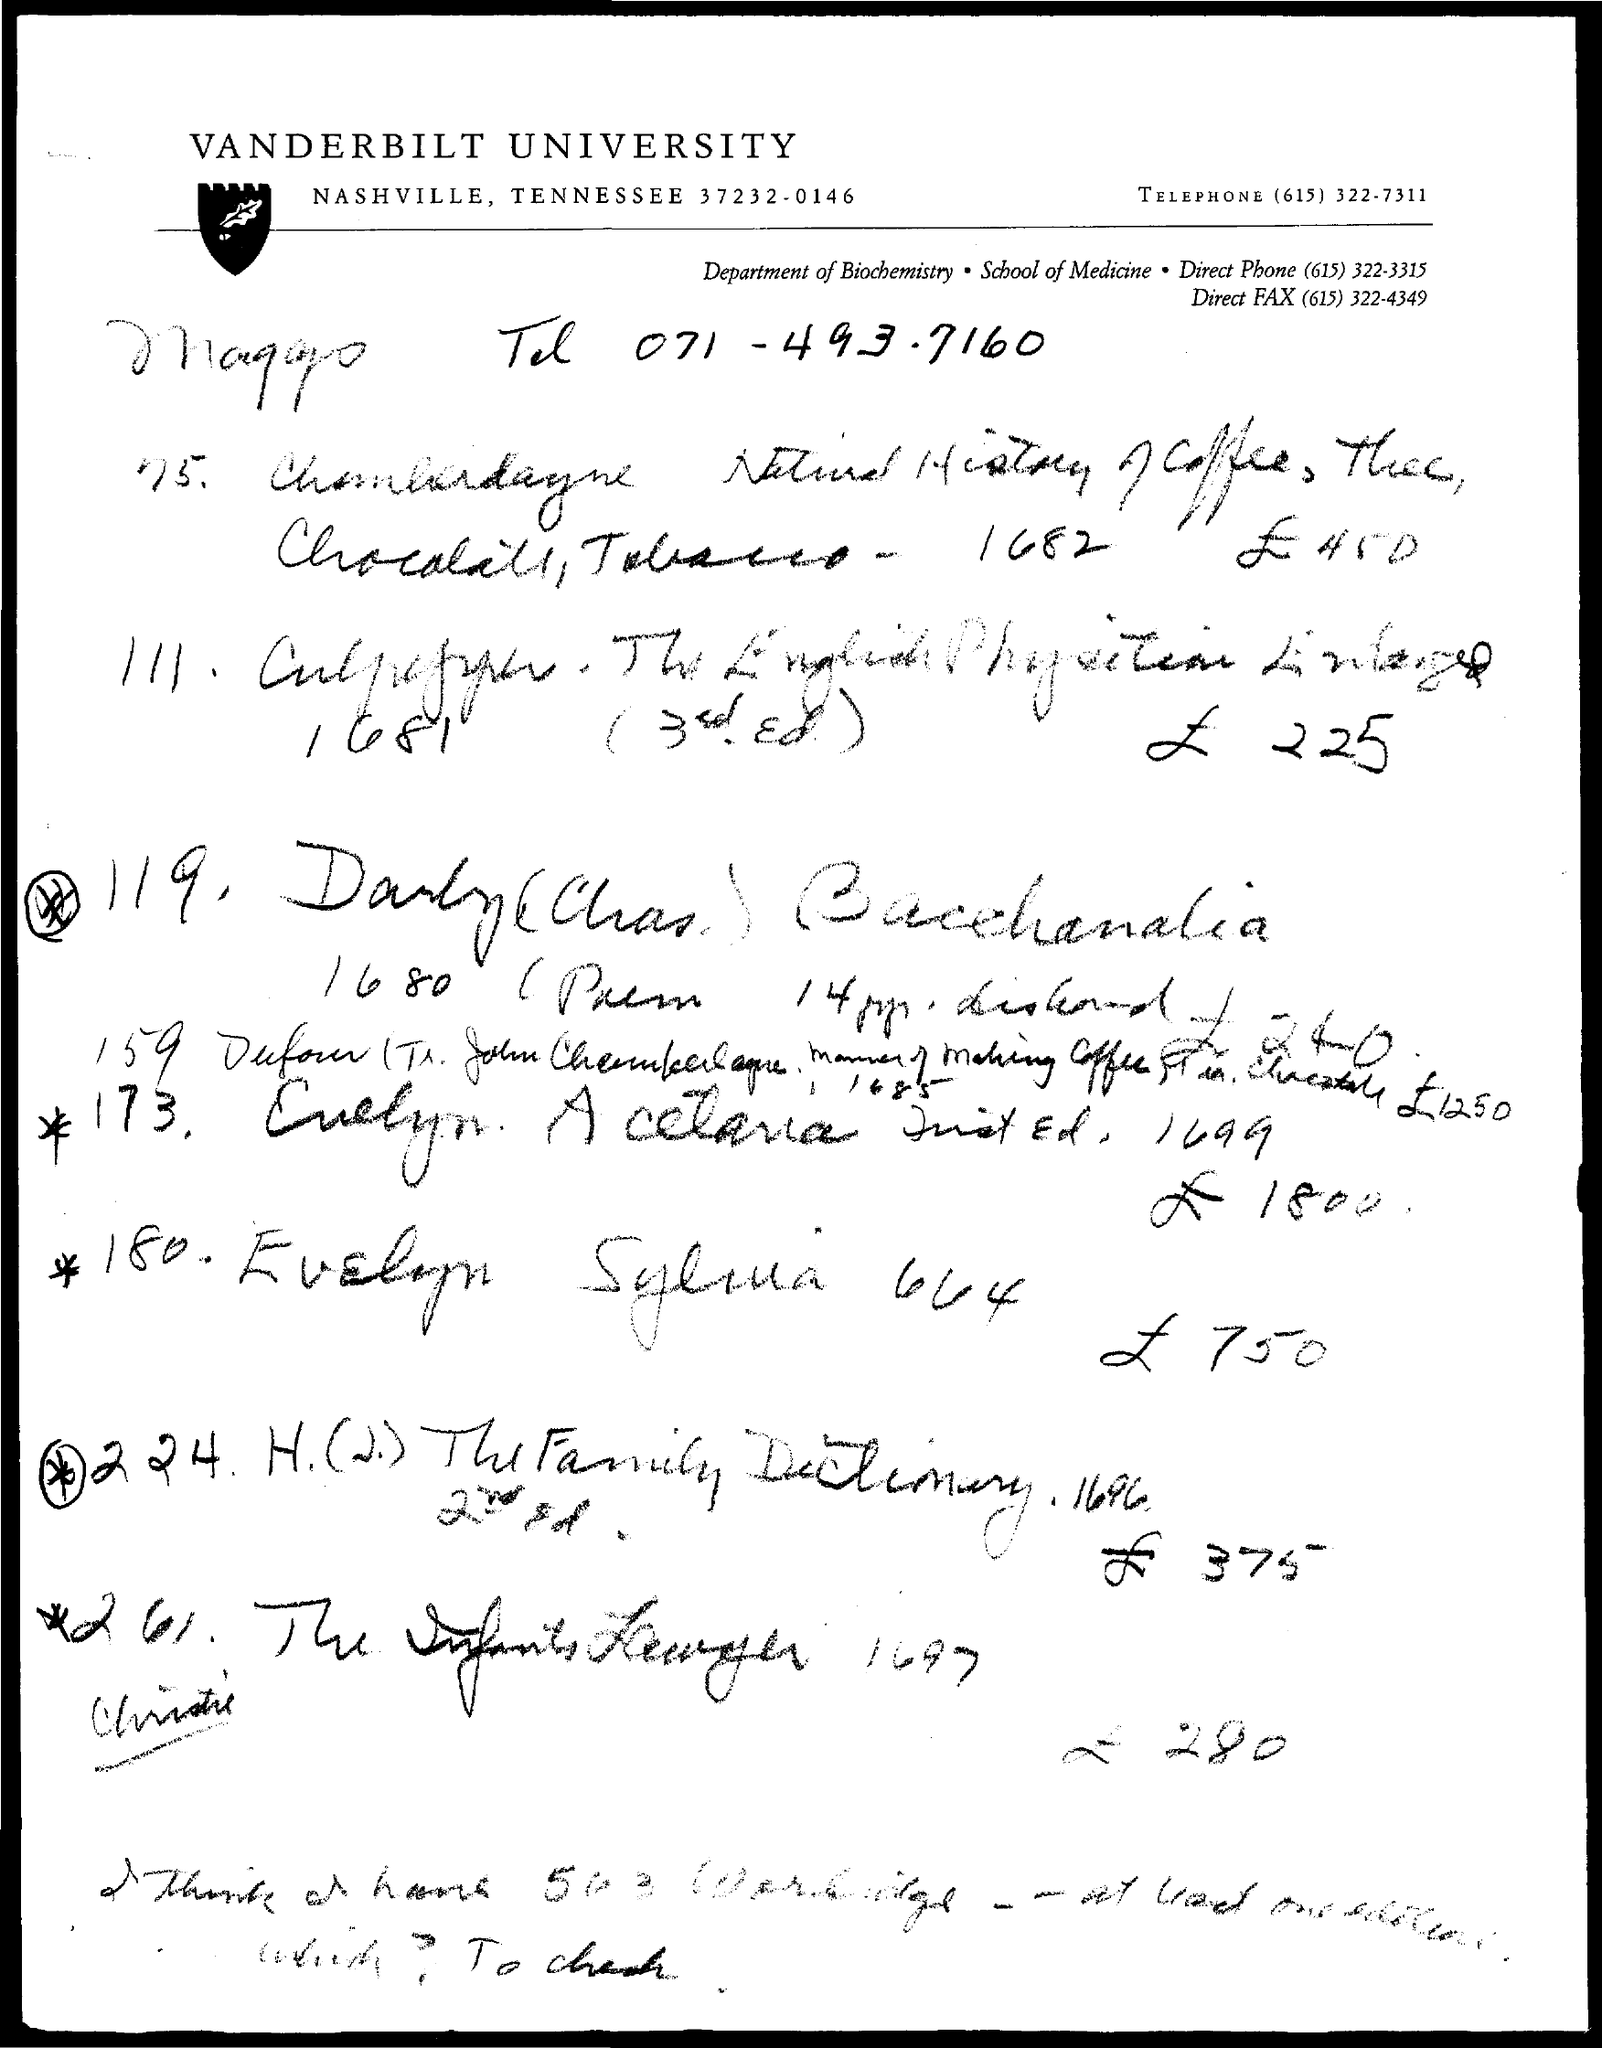Give some essential details in this illustration. The fax number is (615) 322-4349. The document in question is titled "Vanderbilt University. The name of the department is biochemistry. 